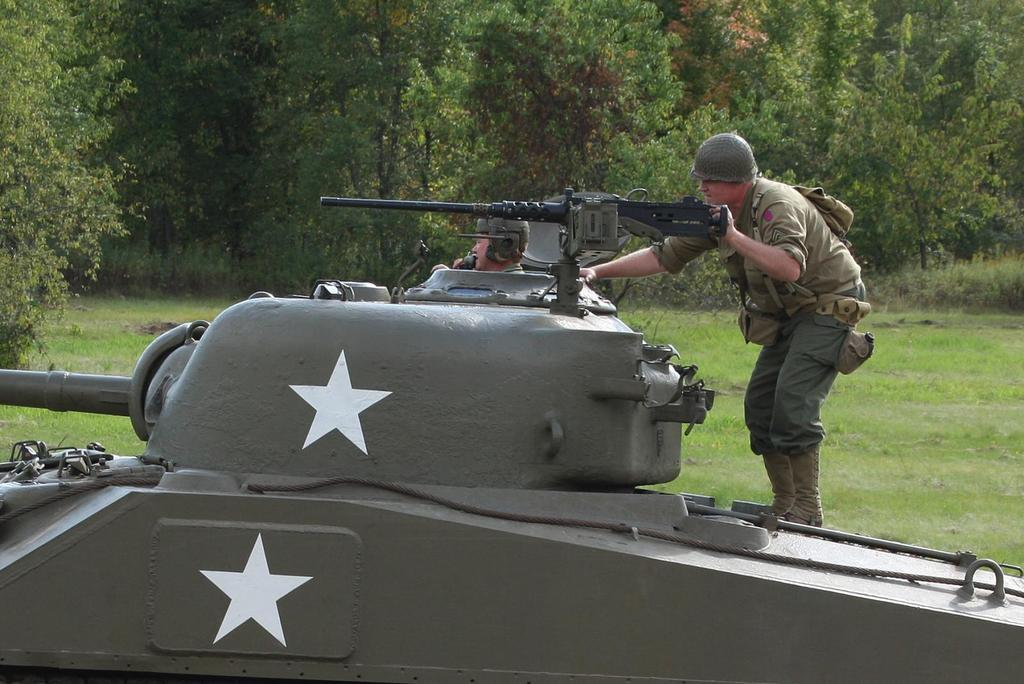How many people are in the image? There are two people in the image. What are the people wearing? Both people are wearing clothes. Can you describe any specific clothing items? One person is wearing a helmet, and the person on the right side is wearing boots. What else can be seen in the image? There is a vehicle, a rifle, grass, and trees visible in the image. How many birds are in the flock that is flying over the trees in the image? There are no birds or flocks visible in the image; it only features two people, a vehicle, a rifle, grass, and trees. 